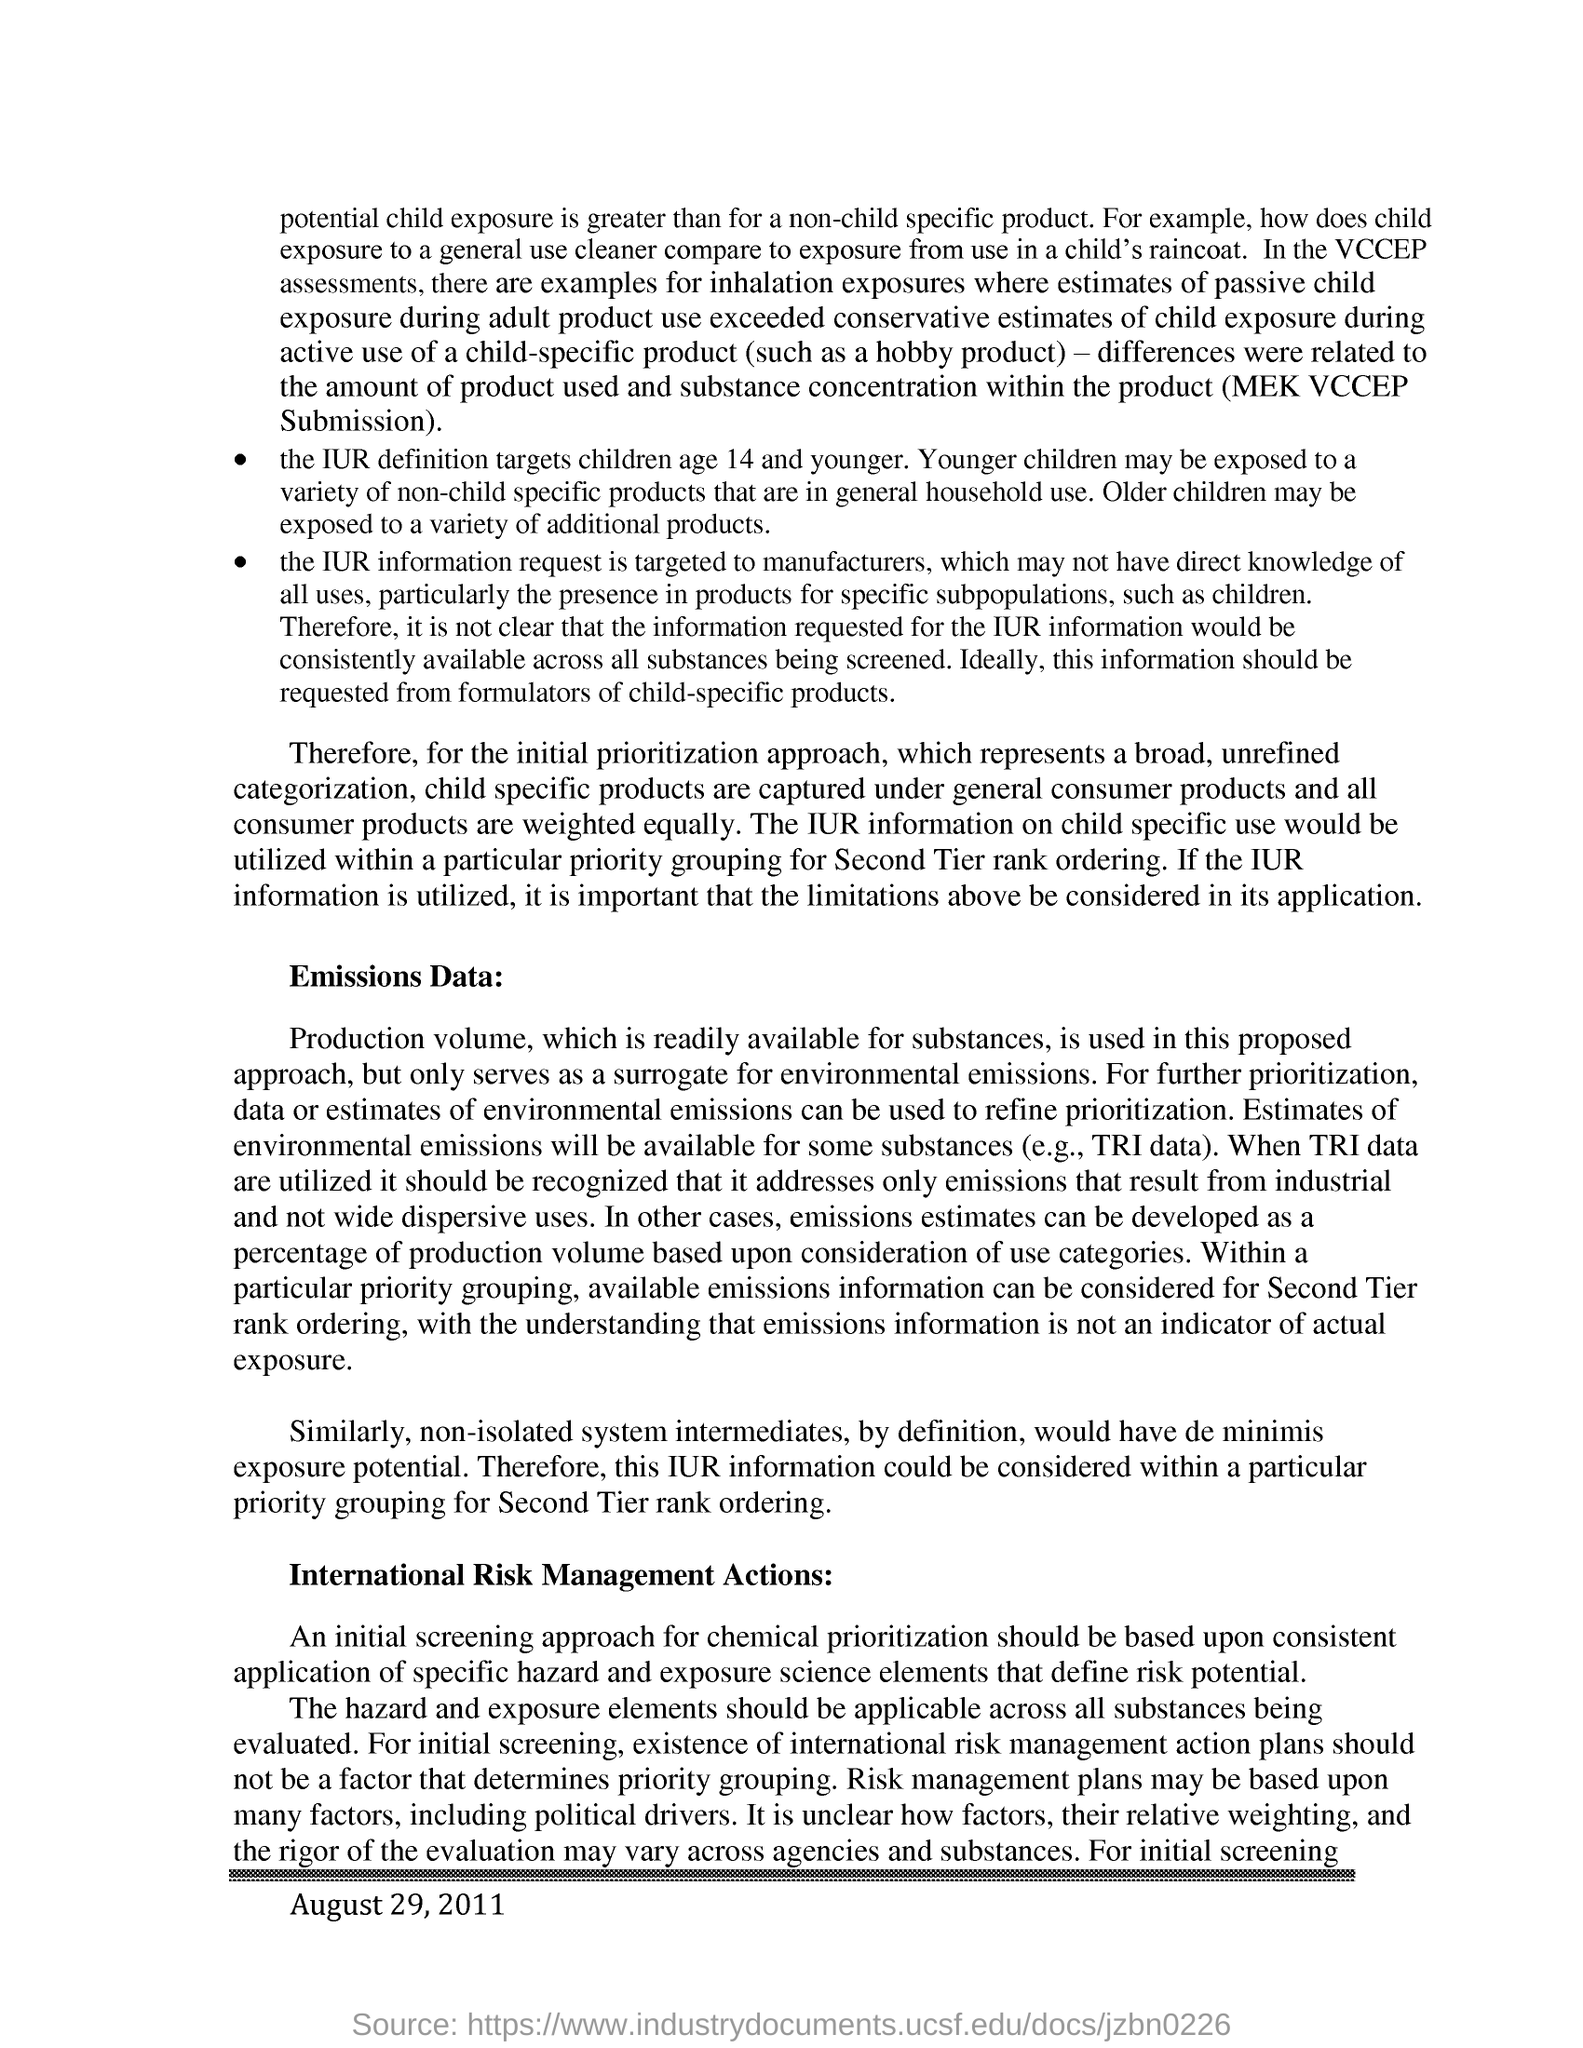Why is it neccessary to consider IUR information within a particular priority grouping?
Give a very brief answer. For second tier rank ordering. Which age group foes the IUR definition target?
Your answer should be very brief. Age 14 and younger. What would have de minimis exposure potential by definition?
Give a very brief answer. Non-isolated system intermediates. On what basis, an initial screening approach for chemical prioritization is done?
Offer a terse response. Based upon consistent application of specific hazard and exposure science elements that define risk potential. 